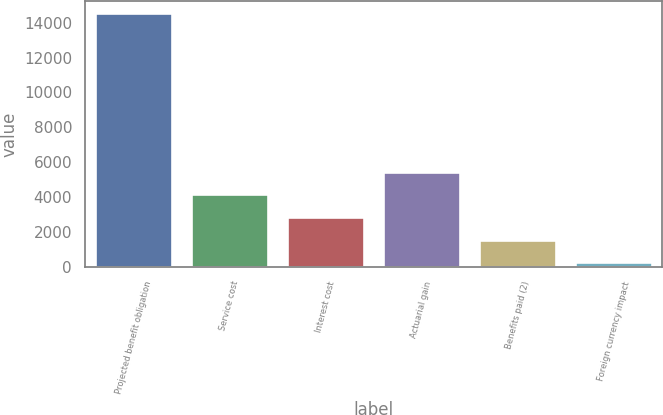<chart> <loc_0><loc_0><loc_500><loc_500><bar_chart><fcel>Projected benefit obligation<fcel>Service cost<fcel>Interest cost<fcel>Actuarial gain<fcel>Benefits paid (2)<fcel>Foreign currency impact<nl><fcel>14526.9<fcel>4165.7<fcel>2862.8<fcel>5468.6<fcel>1559.9<fcel>257<nl></chart> 